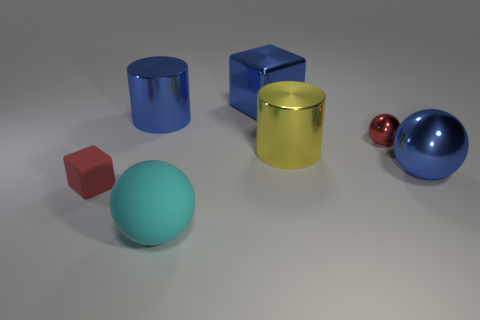What color is the tiny shiny thing that is the same shape as the large matte object?
Your answer should be compact. Red. Are there any other things that have the same material as the yellow object?
Offer a terse response. Yes. There is another metal object that is the same shape as the large yellow object; what is its size?
Your answer should be very brief. Large. There is a object that is on the left side of the big matte object and behind the small block; what material is it?
Offer a very short reply. Metal. Is the color of the metal ball behind the yellow shiny thing the same as the large shiny ball?
Ensure brevity in your answer.  No. There is a large block; is its color the same as the metal object that is on the left side of the blue block?
Offer a terse response. Yes. Are there any shiny things behind the yellow cylinder?
Ensure brevity in your answer.  Yes. Does the tiny block have the same material as the big cube?
Ensure brevity in your answer.  No. What is the material of the blue cube that is the same size as the blue metal sphere?
Provide a short and direct response. Metal. What number of things are balls in front of the tiny red rubber object or big purple shiny spheres?
Your answer should be very brief. 1. 